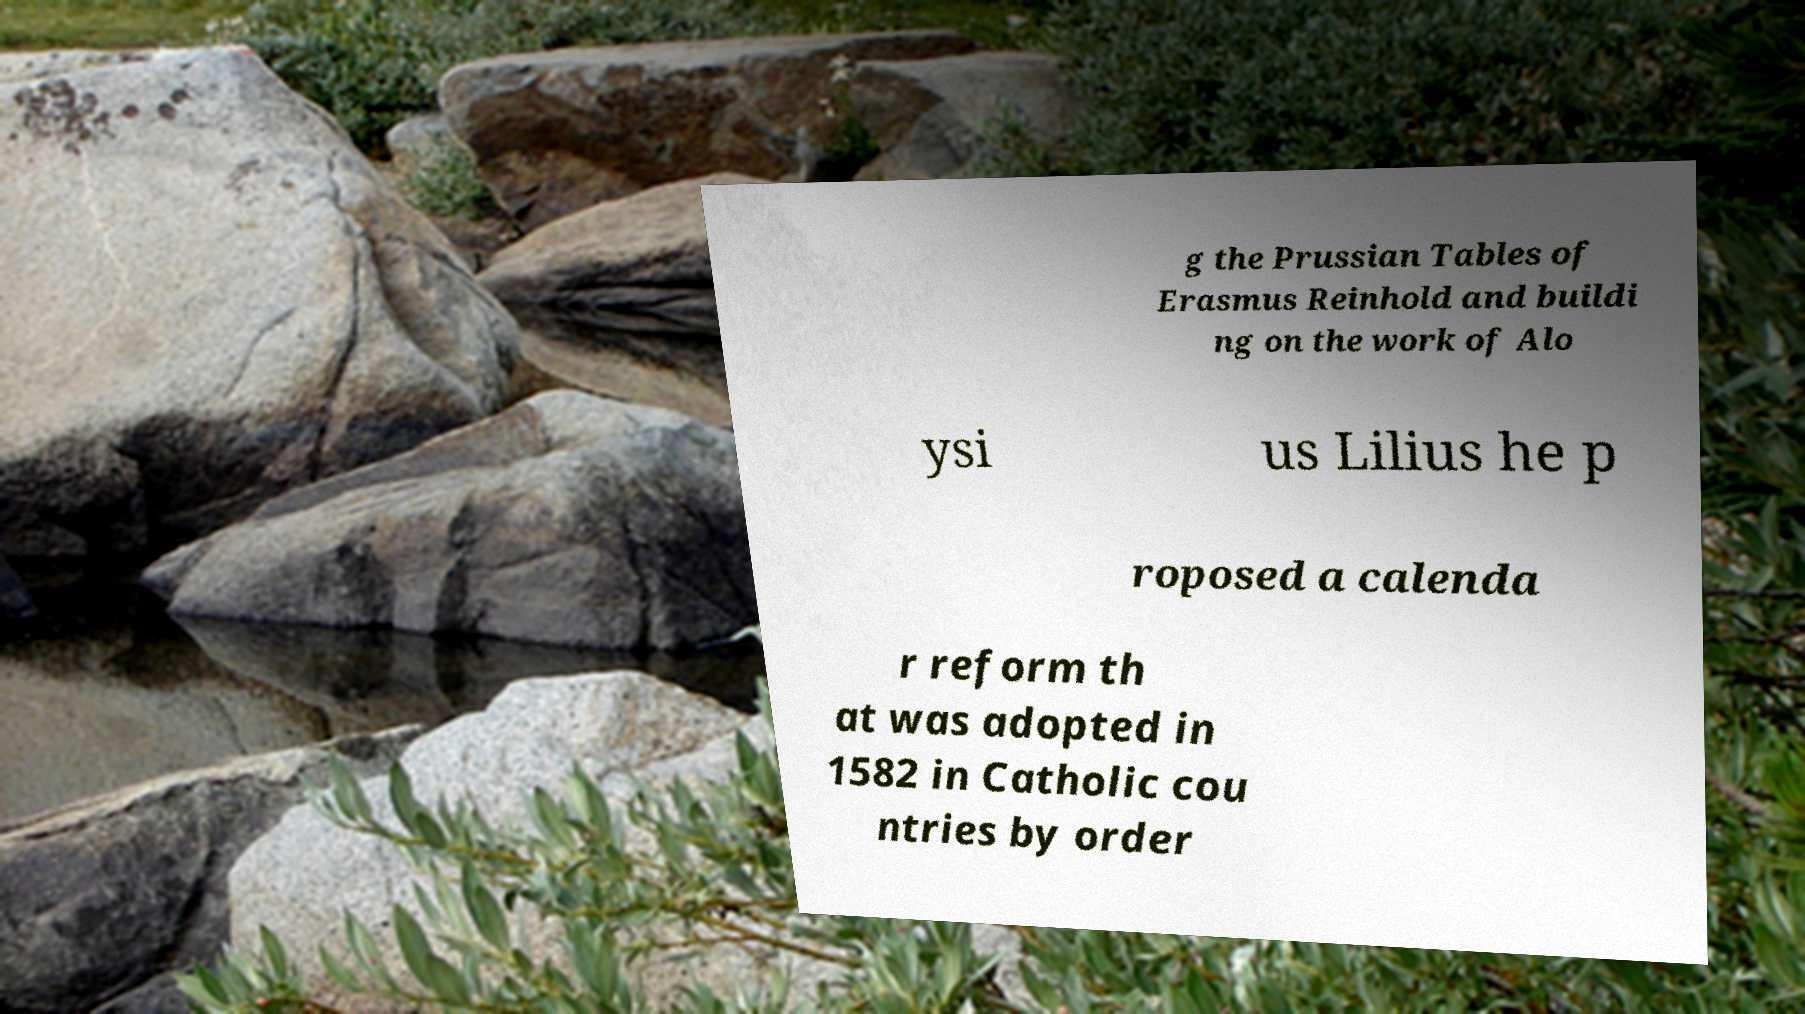Please read and relay the text visible in this image. What does it say? g the Prussian Tables of Erasmus Reinhold and buildi ng on the work of Alo ysi us Lilius he p roposed a calenda r reform th at was adopted in 1582 in Catholic cou ntries by order 